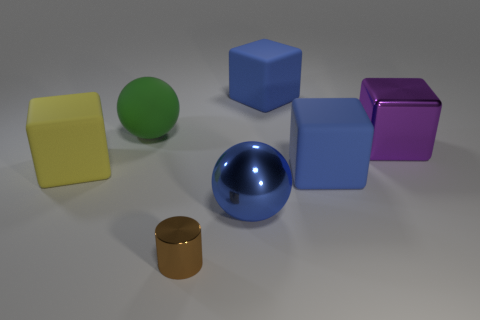What size is the purple thing that is the same material as the large blue ball?
Ensure brevity in your answer.  Large. Is the number of large brown matte balls greater than the number of rubber things?
Provide a short and direct response. No. There is a purple object that is the same size as the rubber ball; what material is it?
Make the answer very short. Metal. Does the matte cube that is on the left side of the metallic cylinder have the same size as the brown thing?
Your answer should be compact. No. How many cubes are either yellow rubber objects or big objects?
Provide a succinct answer. 4. What is the material of the large ball that is on the right side of the small brown thing?
Provide a short and direct response. Metal. Are there fewer brown shiny things than brown shiny blocks?
Your answer should be very brief. No. There is a matte block that is in front of the large purple metal object and on the right side of the yellow rubber block; what size is it?
Provide a short and direct response. Large. There is a rubber cube behind the matte cube that is left of the small metal thing that is in front of the green matte sphere; what size is it?
Offer a very short reply. Large. What number of other things are there of the same color as the shiny sphere?
Give a very brief answer. 2. 